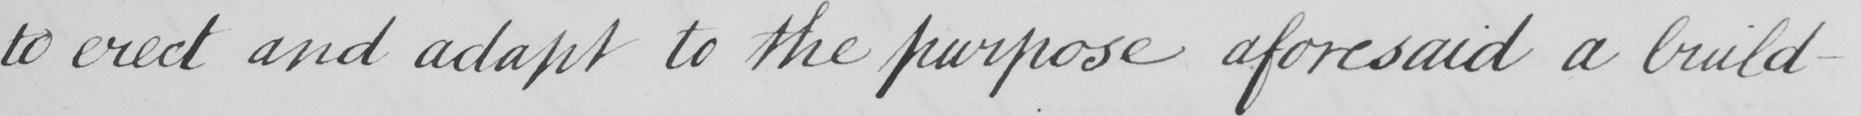Can you read and transcribe this handwriting? to erect and adapt to the purpose aforesaid a build- 